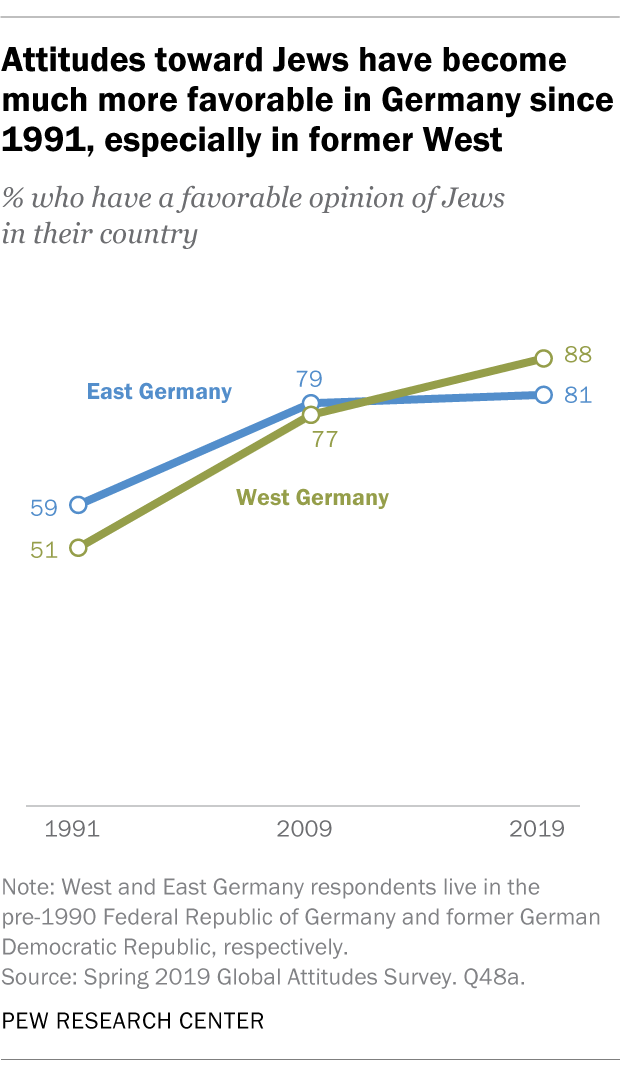Point out several critical features in this image. Is the line with larger changes in values East Germany or West Germany? 